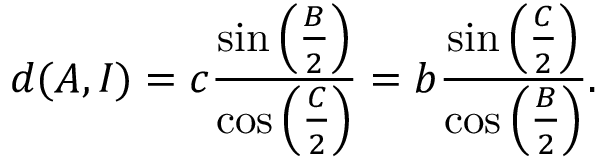Convert formula to latex. <formula><loc_0><loc_0><loc_500><loc_500>d ( A , I ) = c { \frac { \sin \left ( { \frac { B } { 2 } } \right ) } { \cos \left ( { \frac { C } { 2 } } \right ) } } = b { \frac { \sin \left ( { \frac { C } { 2 } } \right ) } { \cos \left ( { \frac { B } { 2 } } \right ) } } .</formula> 